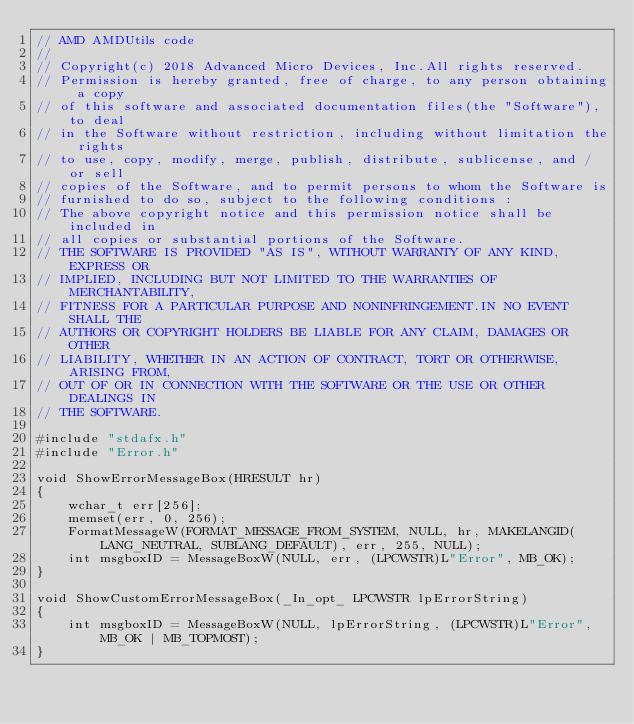Convert code to text. <code><loc_0><loc_0><loc_500><loc_500><_C++_>// AMD AMDUtils code
// 
// Copyright(c) 2018 Advanced Micro Devices, Inc.All rights reserved.
// Permission is hereby granted, free of charge, to any person obtaining a copy
// of this software and associated documentation files(the "Software"), to deal
// in the Software without restriction, including without limitation the rights
// to use, copy, modify, merge, publish, distribute, sublicense, and / or sell
// copies of the Software, and to permit persons to whom the Software is
// furnished to do so, subject to the following conditions :
// The above copyright notice and this permission notice shall be included in
// all copies or substantial portions of the Software.
// THE SOFTWARE IS PROVIDED "AS IS", WITHOUT WARRANTY OF ANY KIND, EXPRESS OR
// IMPLIED, INCLUDING BUT NOT LIMITED TO THE WARRANTIES OF MERCHANTABILITY,
// FITNESS FOR A PARTICULAR PURPOSE AND NONINFRINGEMENT.IN NO EVENT SHALL THE
// AUTHORS OR COPYRIGHT HOLDERS BE LIABLE FOR ANY CLAIM, DAMAGES OR OTHER
// LIABILITY, WHETHER IN AN ACTION OF CONTRACT, TORT OR OTHERWISE, ARISING FROM,
// OUT OF OR IN CONNECTION WITH THE SOFTWARE OR THE USE OR OTHER DEALINGS IN
// THE SOFTWARE.

#include "stdafx.h"
#include "Error.h"

void ShowErrorMessageBox(HRESULT hr)
{
    wchar_t err[256];
    memset(err, 0, 256);
    FormatMessageW(FORMAT_MESSAGE_FROM_SYSTEM, NULL, hr, MAKELANGID(LANG_NEUTRAL, SUBLANG_DEFAULT), err, 255, NULL);
    int msgboxID = MessageBoxW(NULL, err, (LPCWSTR)L"Error", MB_OK);
}

void ShowCustomErrorMessageBox(_In_opt_ LPCWSTR lpErrorString)
{
	int msgboxID = MessageBoxW(NULL, lpErrorString, (LPCWSTR)L"Error", MB_OK | MB_TOPMOST);
}</code> 